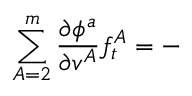Convert formula to latex. <formula><loc_0><loc_0><loc_500><loc_500>\sum _ { A = 2 } ^ { m } \frac { \partial \phi ^ { a } } { \partial v ^ { A } } f _ { t } ^ { A } = -</formula> 